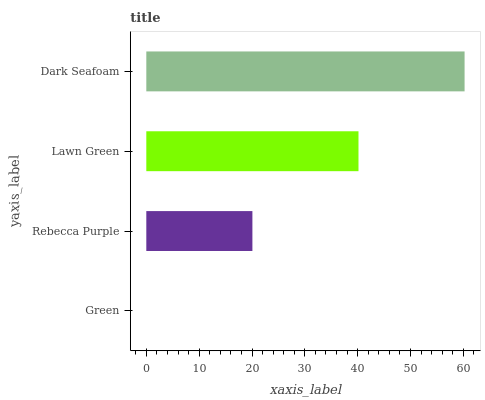Is Green the minimum?
Answer yes or no. Yes. Is Dark Seafoam the maximum?
Answer yes or no. Yes. Is Rebecca Purple the minimum?
Answer yes or no. No. Is Rebecca Purple the maximum?
Answer yes or no. No. Is Rebecca Purple greater than Green?
Answer yes or no. Yes. Is Green less than Rebecca Purple?
Answer yes or no. Yes. Is Green greater than Rebecca Purple?
Answer yes or no. No. Is Rebecca Purple less than Green?
Answer yes or no. No. Is Lawn Green the high median?
Answer yes or no. Yes. Is Rebecca Purple the low median?
Answer yes or no. Yes. Is Green the high median?
Answer yes or no. No. Is Green the low median?
Answer yes or no. No. 